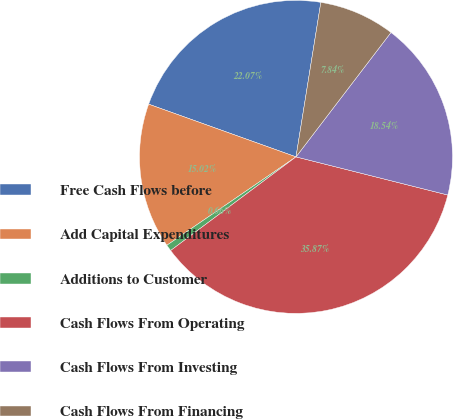Convert chart to OTSL. <chart><loc_0><loc_0><loc_500><loc_500><pie_chart><fcel>Free Cash Flows before<fcel>Add Capital Expenditures<fcel>Additions to Customer<fcel>Cash Flows From Operating<fcel>Cash Flows From Investing<fcel>Cash Flows From Financing<nl><fcel>22.07%<fcel>15.02%<fcel>0.66%<fcel>35.87%<fcel>18.54%<fcel>7.84%<nl></chart> 